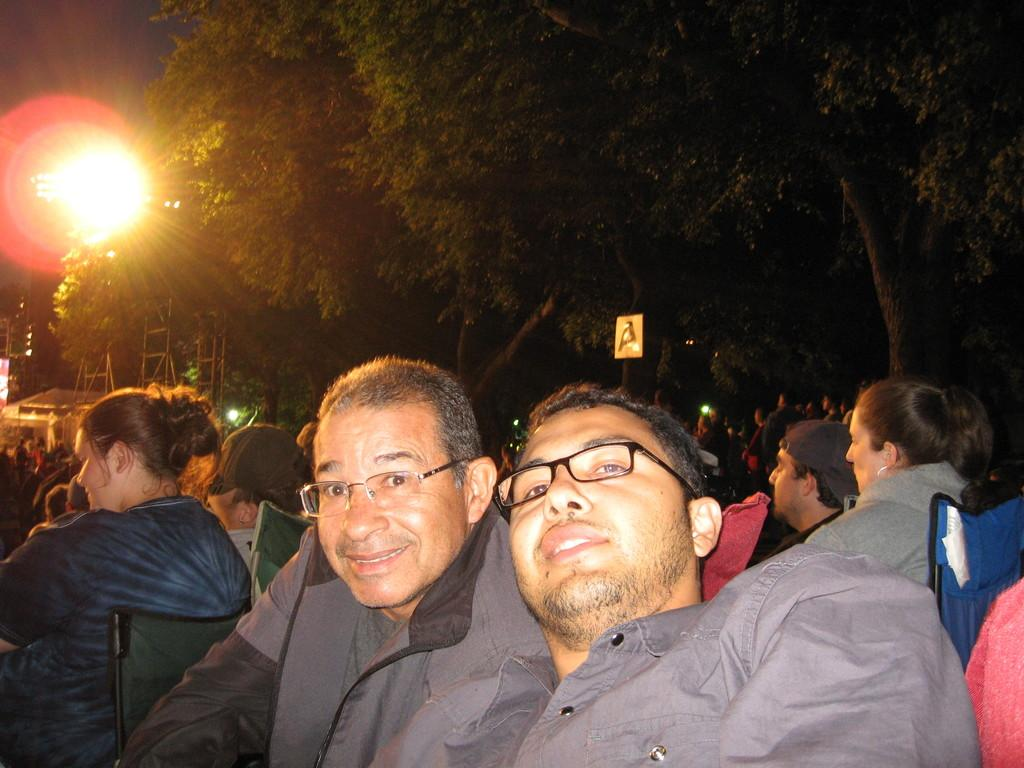How many people are in the image? There are people in the image, but the exact number is not specified. What can be observed about the people in the image? The people are in one place. What type of natural environment is visible in the background of the image? There are trees visible in the background of the image. What type of light is visible in the background of the image? There is light visible in the background of the image. What type of vegetable is being harvested by the people in the image? There is no indication in the image that the people are harvesting any vegetable. What type of industry is depicted in the image? There is no industry depicted in the image; it features people in one place with trees visible in the background. What type of wealth is being displayed by the people in the image? There is no indication in the image that the people are displaying any wealth. 